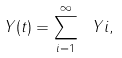<formula> <loc_0><loc_0><loc_500><loc_500>Y ( t ) = \sum _ { i = 1 } ^ { \infty } \ Y i ,</formula> 